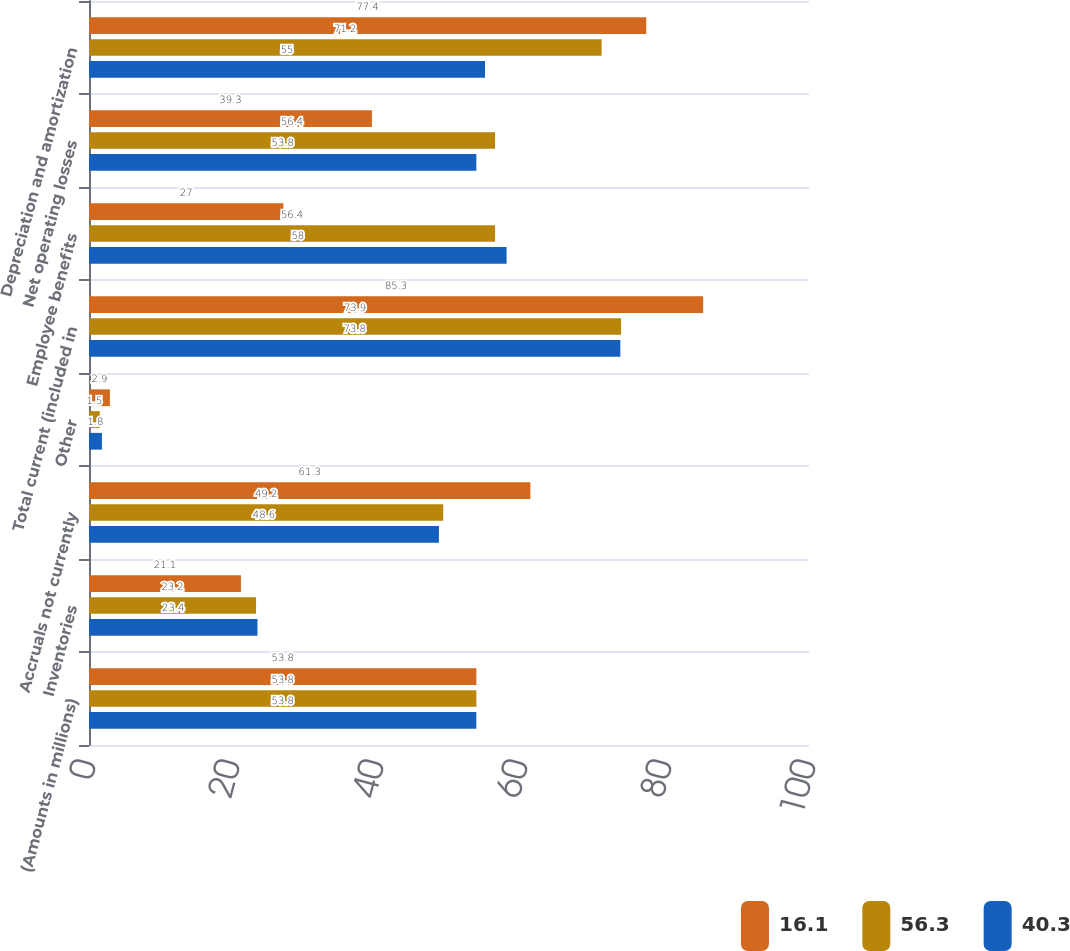<chart> <loc_0><loc_0><loc_500><loc_500><stacked_bar_chart><ecel><fcel>(Amounts in millions)<fcel>Inventories<fcel>Accruals not currently<fcel>Other<fcel>Total current (included in<fcel>Employee benefits<fcel>Net operating losses<fcel>Depreciation and amortization<nl><fcel>16.1<fcel>53.8<fcel>21.1<fcel>61.3<fcel>2.9<fcel>85.3<fcel>27<fcel>39.3<fcel>77.4<nl><fcel>56.3<fcel>53.8<fcel>23.2<fcel>49.2<fcel>1.5<fcel>73.9<fcel>56.4<fcel>56.4<fcel>71.2<nl><fcel>40.3<fcel>53.8<fcel>23.4<fcel>48.6<fcel>1.8<fcel>73.8<fcel>58<fcel>53.8<fcel>55<nl></chart> 